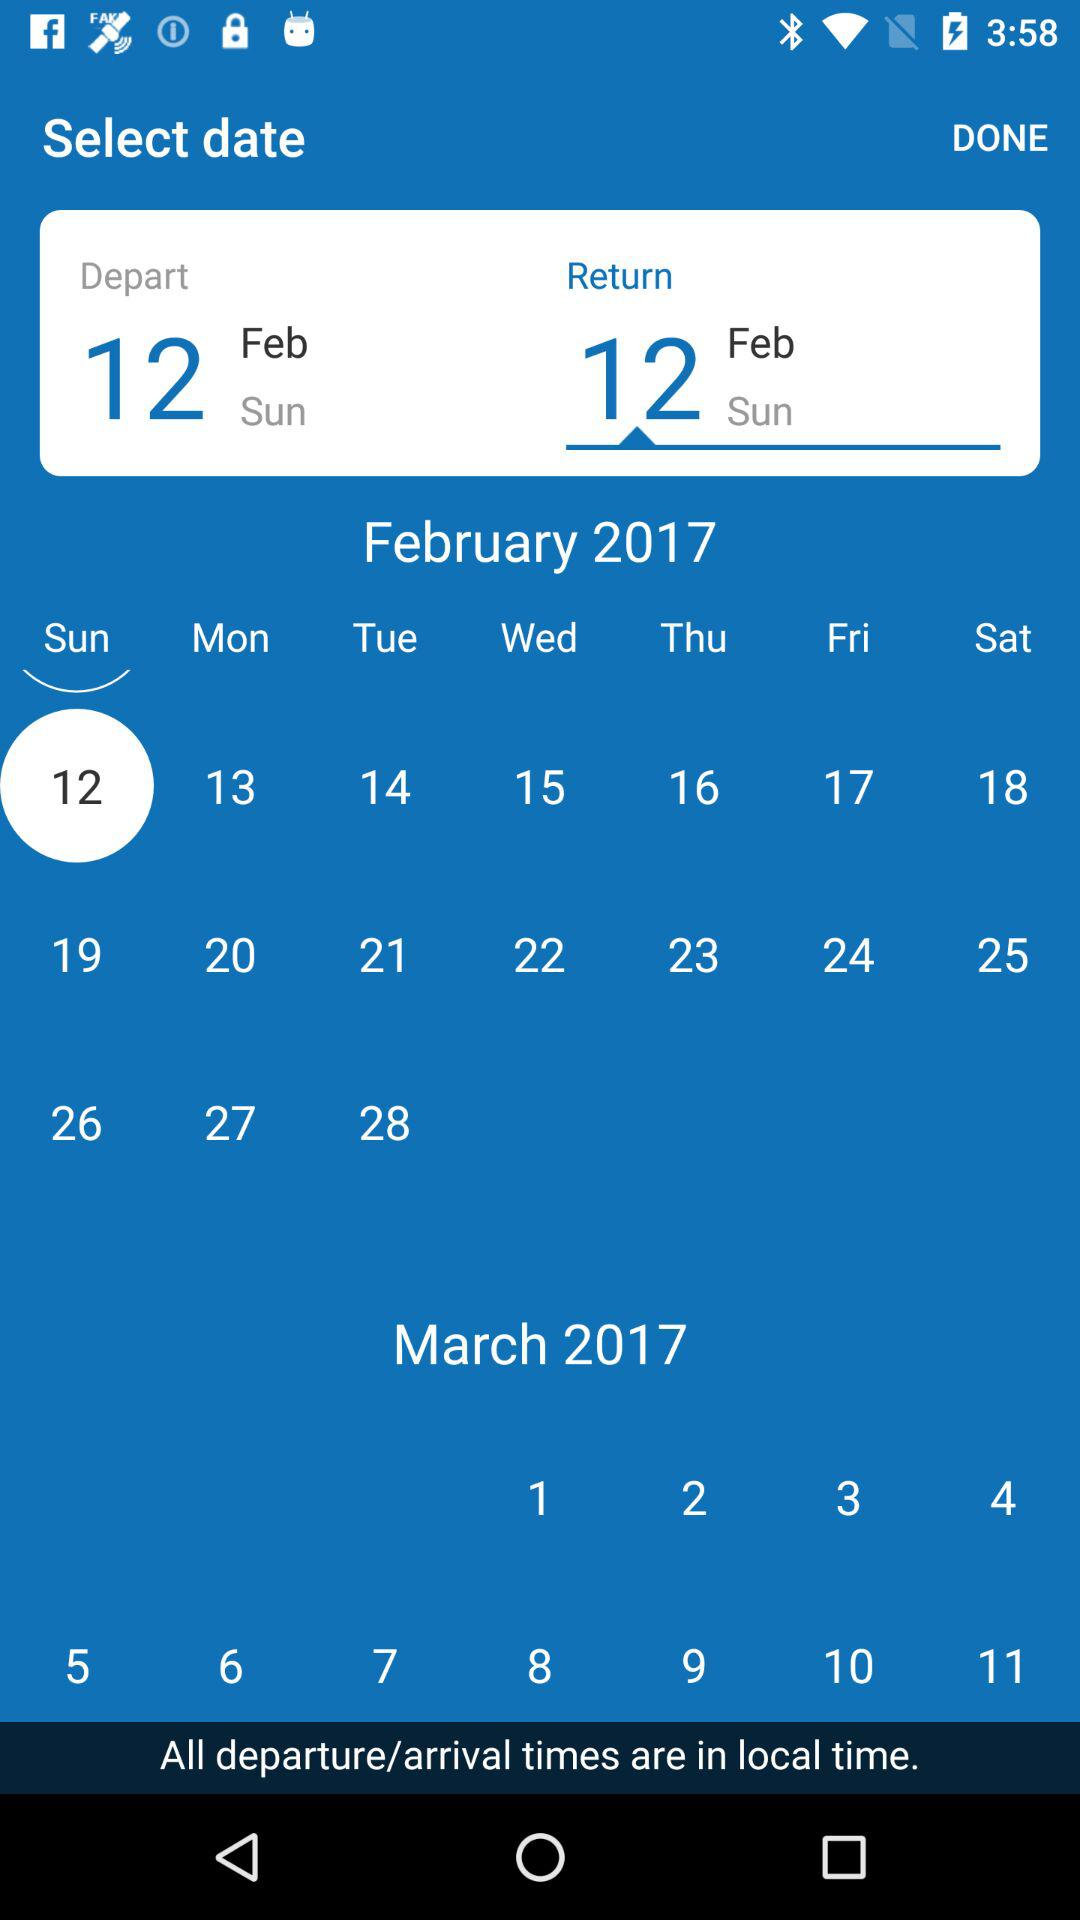What day is it on February 12? The day is Sunday. 